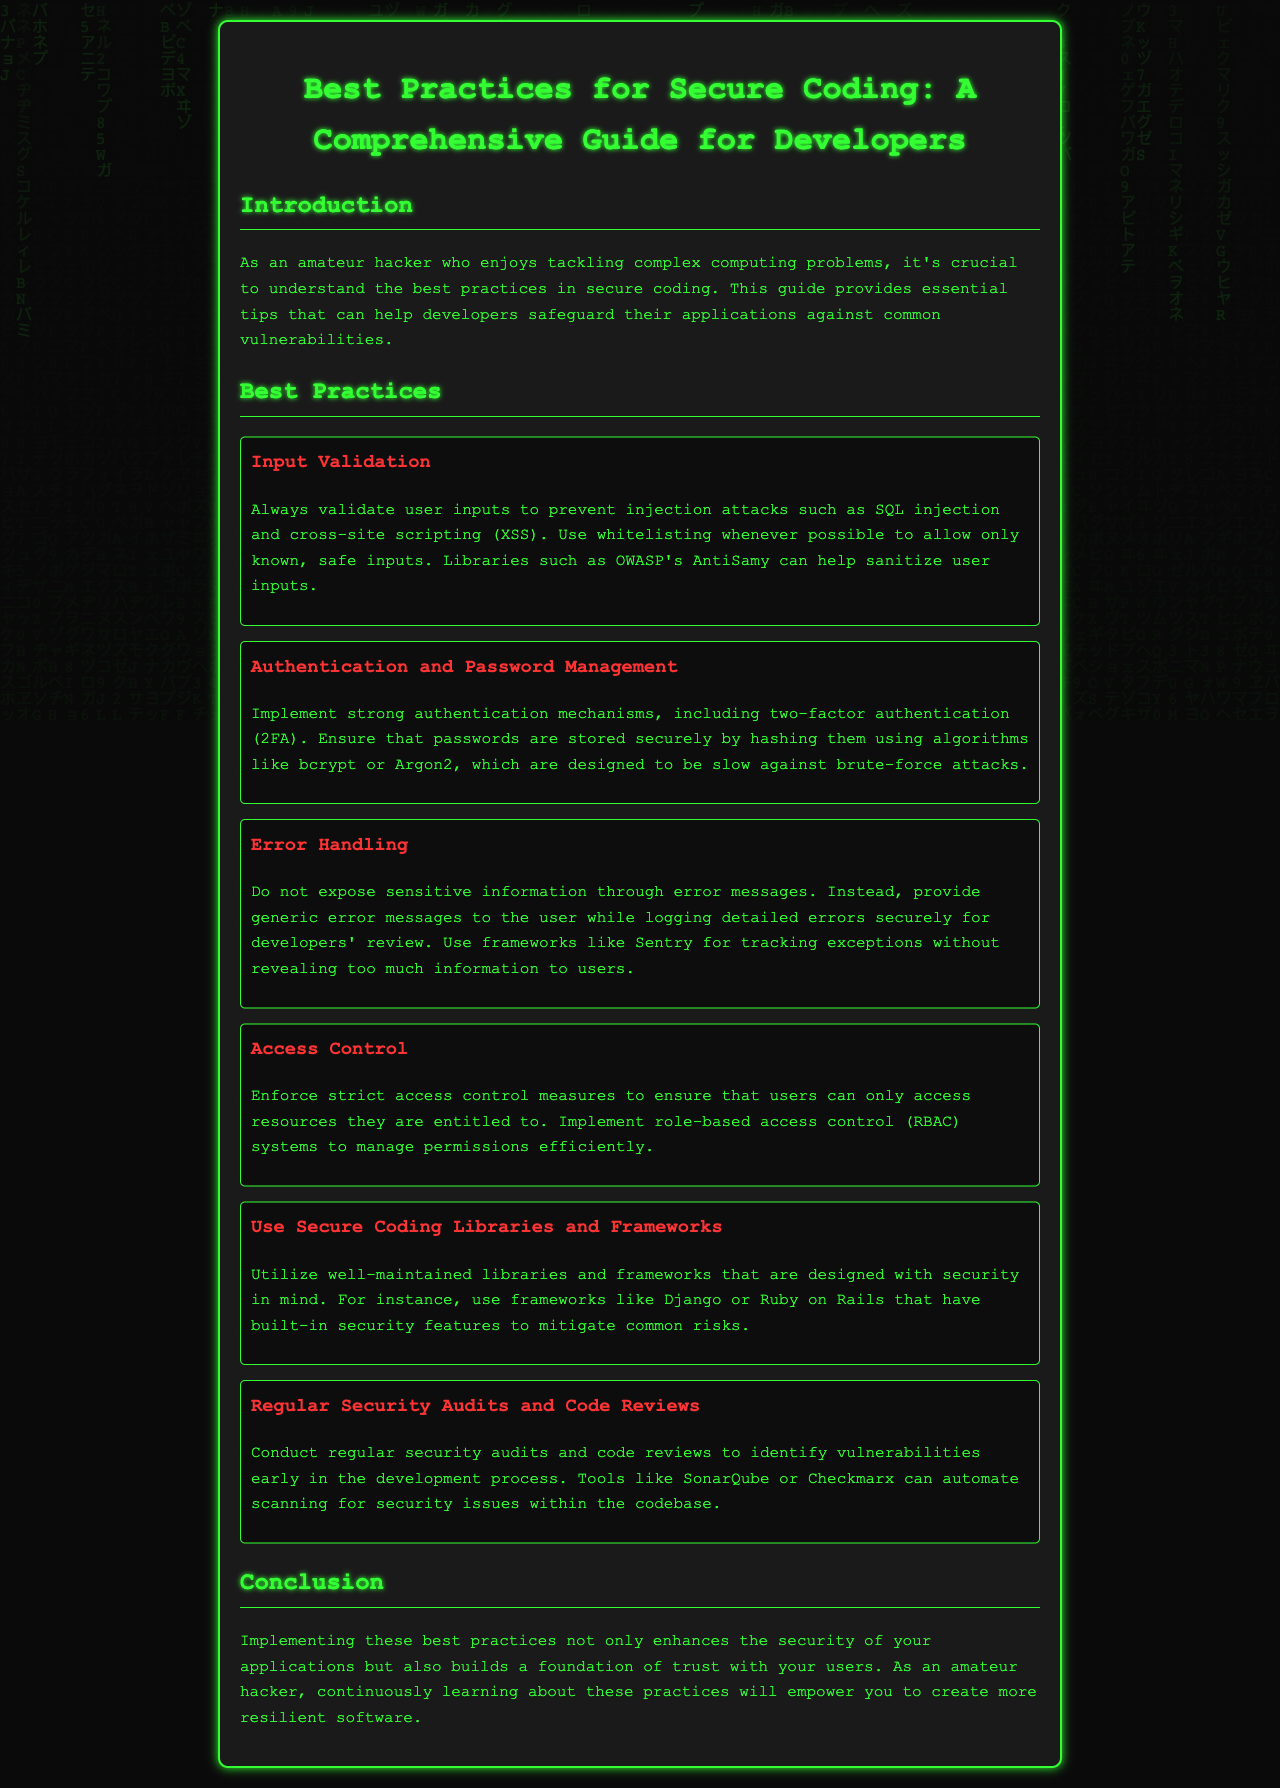What is the title of the document? The title of the document is provided in the header section.
Answer: Best Practices for Secure Coding: A Comprehensive Guide for Developers What is the first best practice listed? The best practices are organized in sections, starting with "Input Validation".
Answer: Input Validation How should passwords be stored securely? The document specifies the methods to securely store passwords, emphasizing the use of hashing algorithms.
Answer: By hashing them using algorithms like bcrypt or Argon2 What tool is mentioned for tracking exceptions? A specific tool is recommended for tracking exceptions without revealing sensitive information.
Answer: Sentry How often should security audits be conducted? The guide suggests a proactive approach, indicating regularity in security audits to catch vulnerabilities early.
Answer: Regularly What is emphasized in the conclusion? The conclusion reinforces the importance of implementing security practices for building user trust.
Answer: Building a foundation of trust with your users Which coding frameworks are suggested for secure development? The document provides examples of frameworks that are designed with security in mind.
Answer: Django or Ruby on Rails What is a recommended measure for access control? The document discusses specific strategies for managing user access effectively.
Answer: Role-based access control (RBAC) systems 